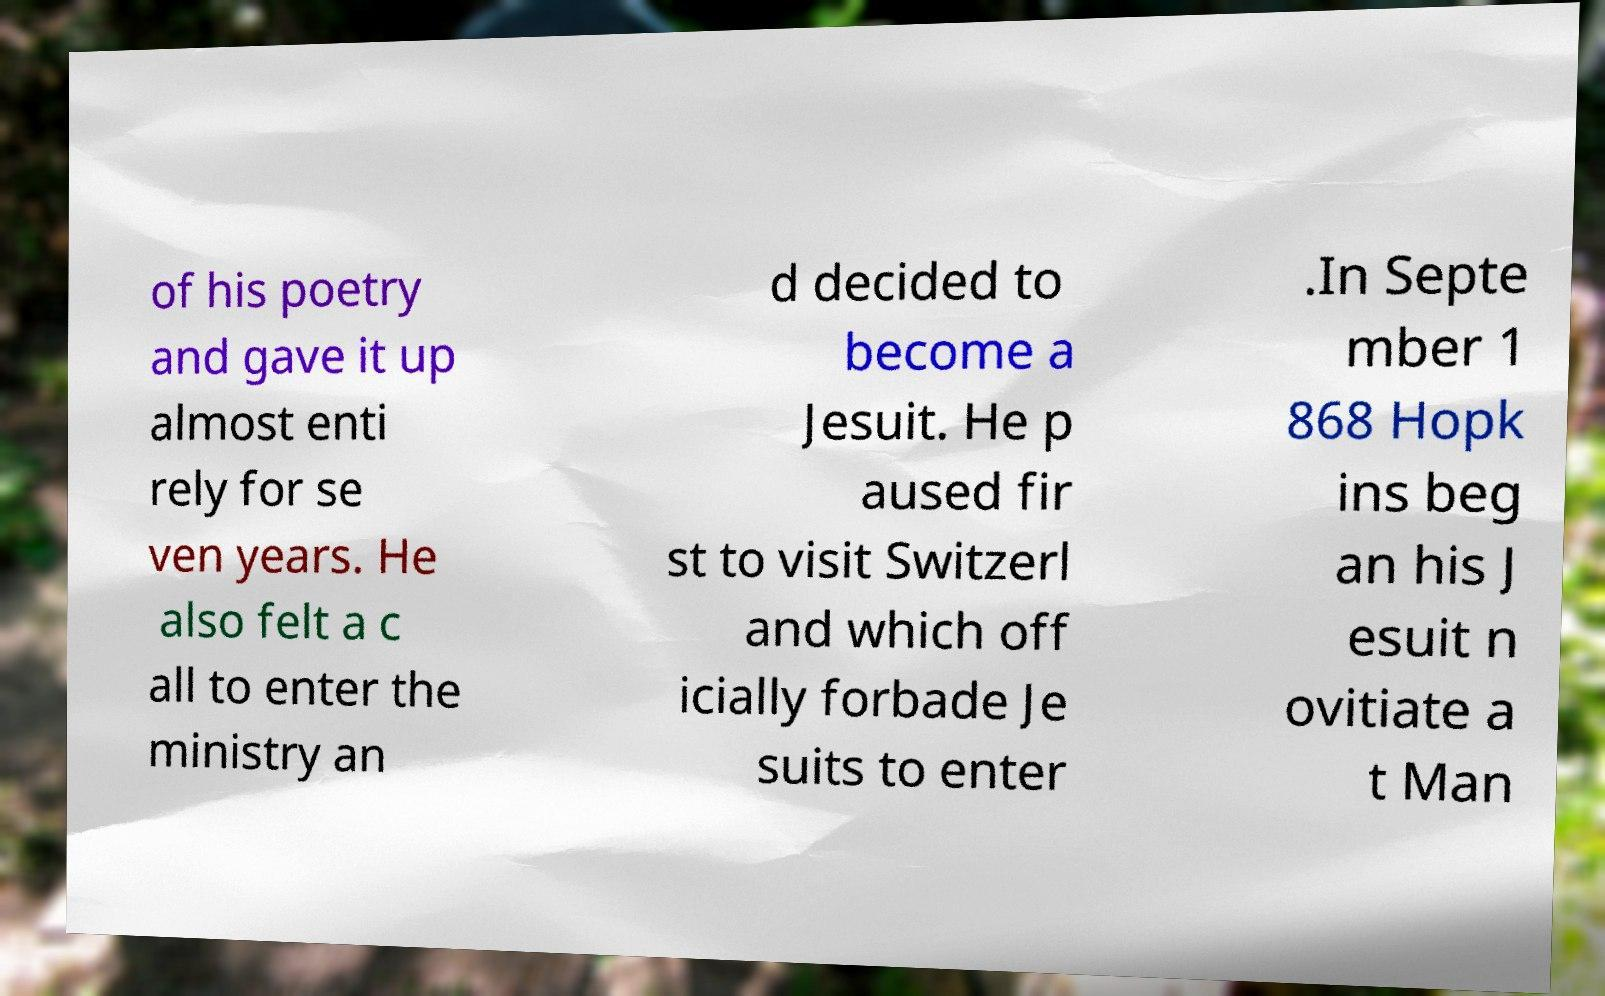Could you extract and type out the text from this image? of his poetry and gave it up almost enti rely for se ven years. He also felt a c all to enter the ministry an d decided to become a Jesuit. He p aused fir st to visit Switzerl and which off icially forbade Je suits to enter .In Septe mber 1 868 Hopk ins beg an his J esuit n ovitiate a t Man 